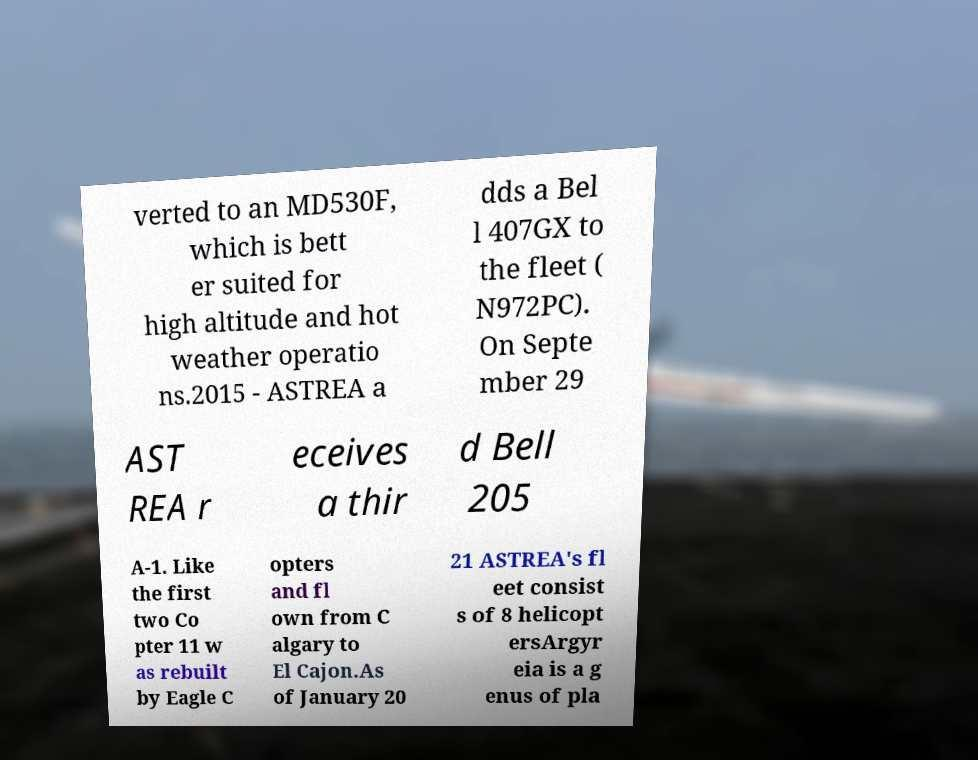Can you accurately transcribe the text from the provided image for me? verted to an MD530F, which is bett er suited for high altitude and hot weather operatio ns.2015 - ASTREA a dds a Bel l 407GX to the fleet ( N972PC). On Septe mber 29 AST REA r eceives a thir d Bell 205 A-1. Like the first two Co pter 11 w as rebuilt by Eagle C opters and fl own from C algary to El Cajon.As of January 20 21 ASTREA's fl eet consist s of 8 helicopt ersArgyr eia is a g enus of pla 